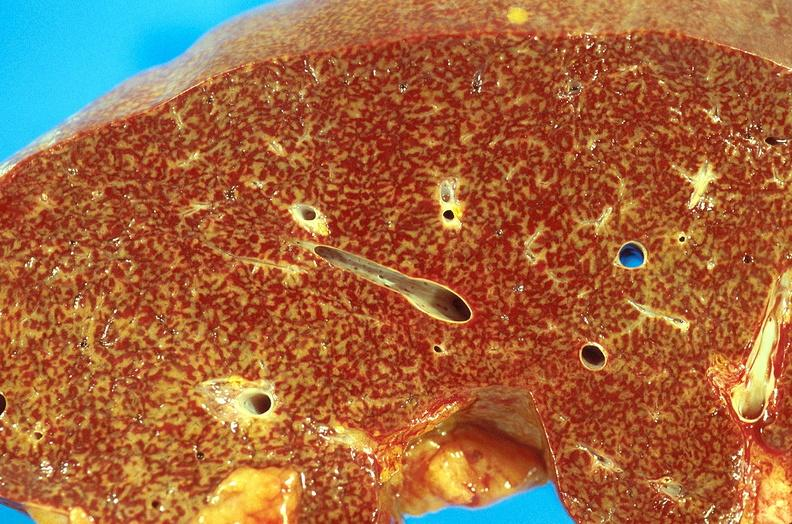does this image show chronic passive congestion, liver?
Answer the question using a single word or phrase. Yes 